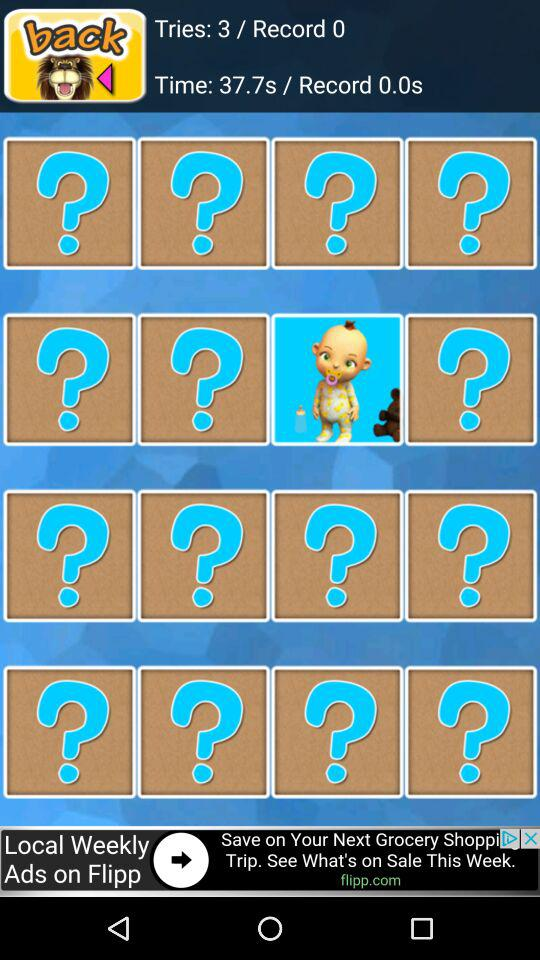How many questions are there in the first row of the screen?
Answer the question using a single word or phrase. 4 